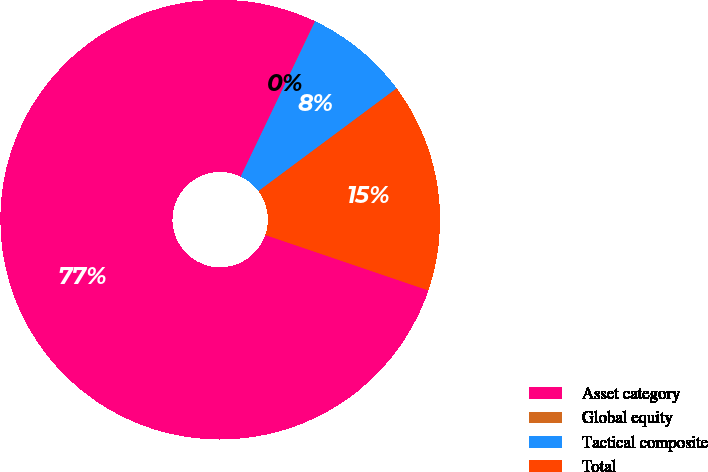Convert chart. <chart><loc_0><loc_0><loc_500><loc_500><pie_chart><fcel>Asset category<fcel>Global equity<fcel>Tactical composite<fcel>Total<nl><fcel>76.88%<fcel>0.02%<fcel>7.71%<fcel>15.39%<nl></chart> 